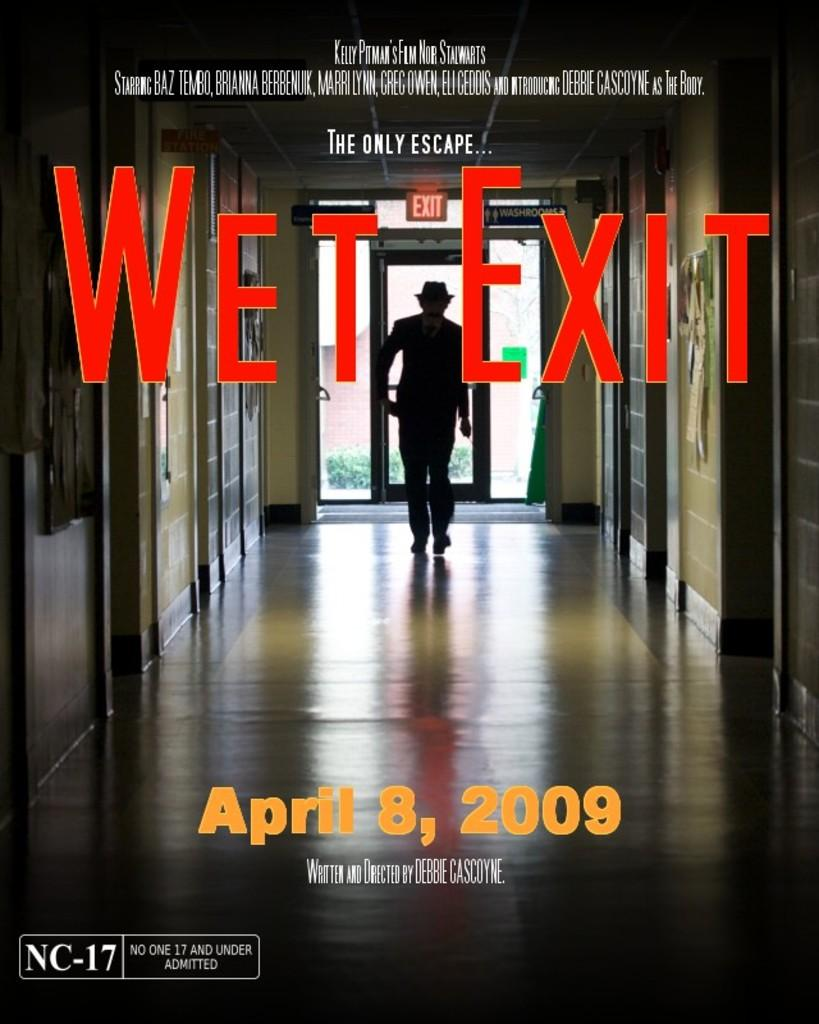What is the nature of the image? The image is edited. What is the main subject of the image? There is a person walking in the center of the image. Are there any words or phrases in the image? Yes, there is text in the image. What type of architectural feature can be seen in the image? There are doors in the image. What is visible at the bottom of the image? There is a floor visible at the bottom of the image. How many bags can be seen hanging from the person's shoulders in the image? There are no bags visible on the person's shoulders in the image. What type of birds can be seen flying in the background of the image? There are no birds present in the image. 